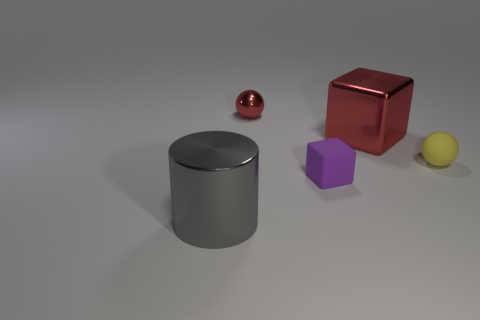There is a rubber thing that is to the left of the large thing behind the big gray shiny thing; how big is it?
Provide a short and direct response. Small. There is a ball behind the small ball in front of the tiny sphere left of the small purple thing; what color is it?
Ensure brevity in your answer.  Red. How big is the thing that is on the right side of the small red shiny sphere and left of the big red block?
Offer a terse response. Small. What number of other things are there of the same shape as the purple matte object?
Keep it short and to the point. 1. How many spheres are large metallic things or large gray things?
Make the answer very short. 0. There is a red thing right of the red object that is left of the big red shiny cube; is there a small rubber sphere in front of it?
Your response must be concise. Yes. What color is the tiny matte thing that is the same shape as the small red metallic object?
Provide a short and direct response. Yellow. What number of purple objects are either small matte things or small matte balls?
Ensure brevity in your answer.  1. What material is the red sphere on the left side of the large object that is right of the big gray thing?
Keep it short and to the point. Metal. Is the shape of the small purple object the same as the tiny yellow matte thing?
Provide a short and direct response. No. 